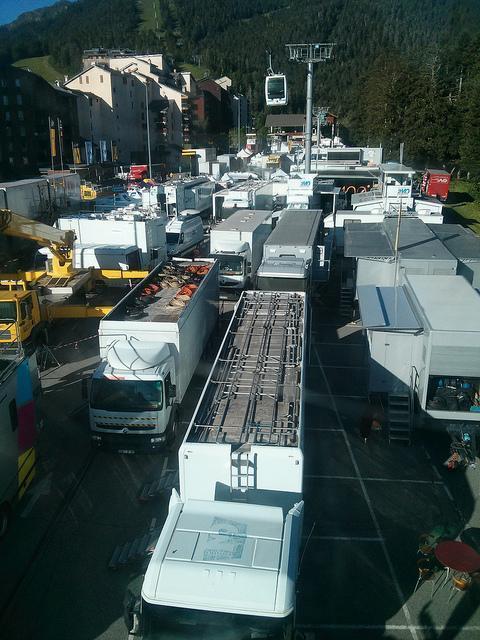How many trucks are in the photo?
Give a very brief answer. 4. How many animals have a bird on their back?
Give a very brief answer. 0. 